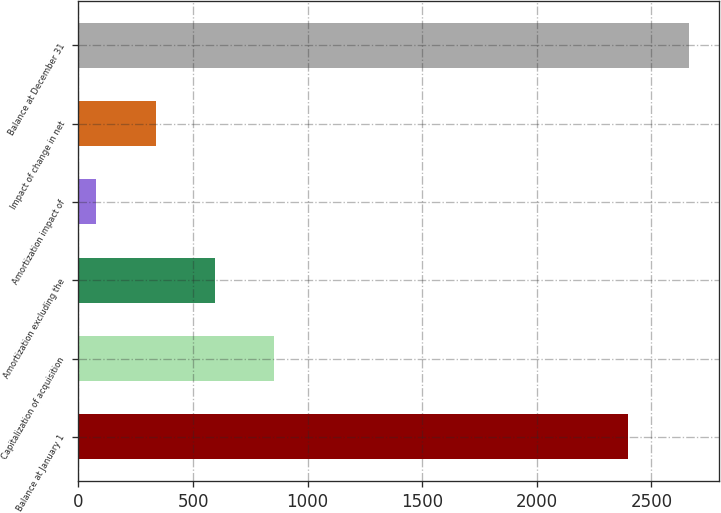Convert chart to OTSL. <chart><loc_0><loc_0><loc_500><loc_500><bar_chart><fcel>Balance at January 1<fcel>Capitalization of acquisition<fcel>Amortization excluding the<fcel>Amortization impact of<fcel>Impact of change in net<fcel>Balance at December 31<nl><fcel>2399<fcel>853.5<fcel>595<fcel>78<fcel>336.5<fcel>2663<nl></chart> 